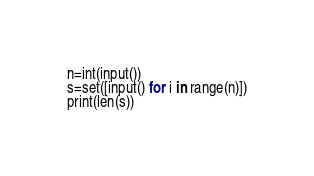Convert code to text. <code><loc_0><loc_0><loc_500><loc_500><_Python_>n=int(input())
s=set([input() for i in range(n)])
print(len(s))</code> 